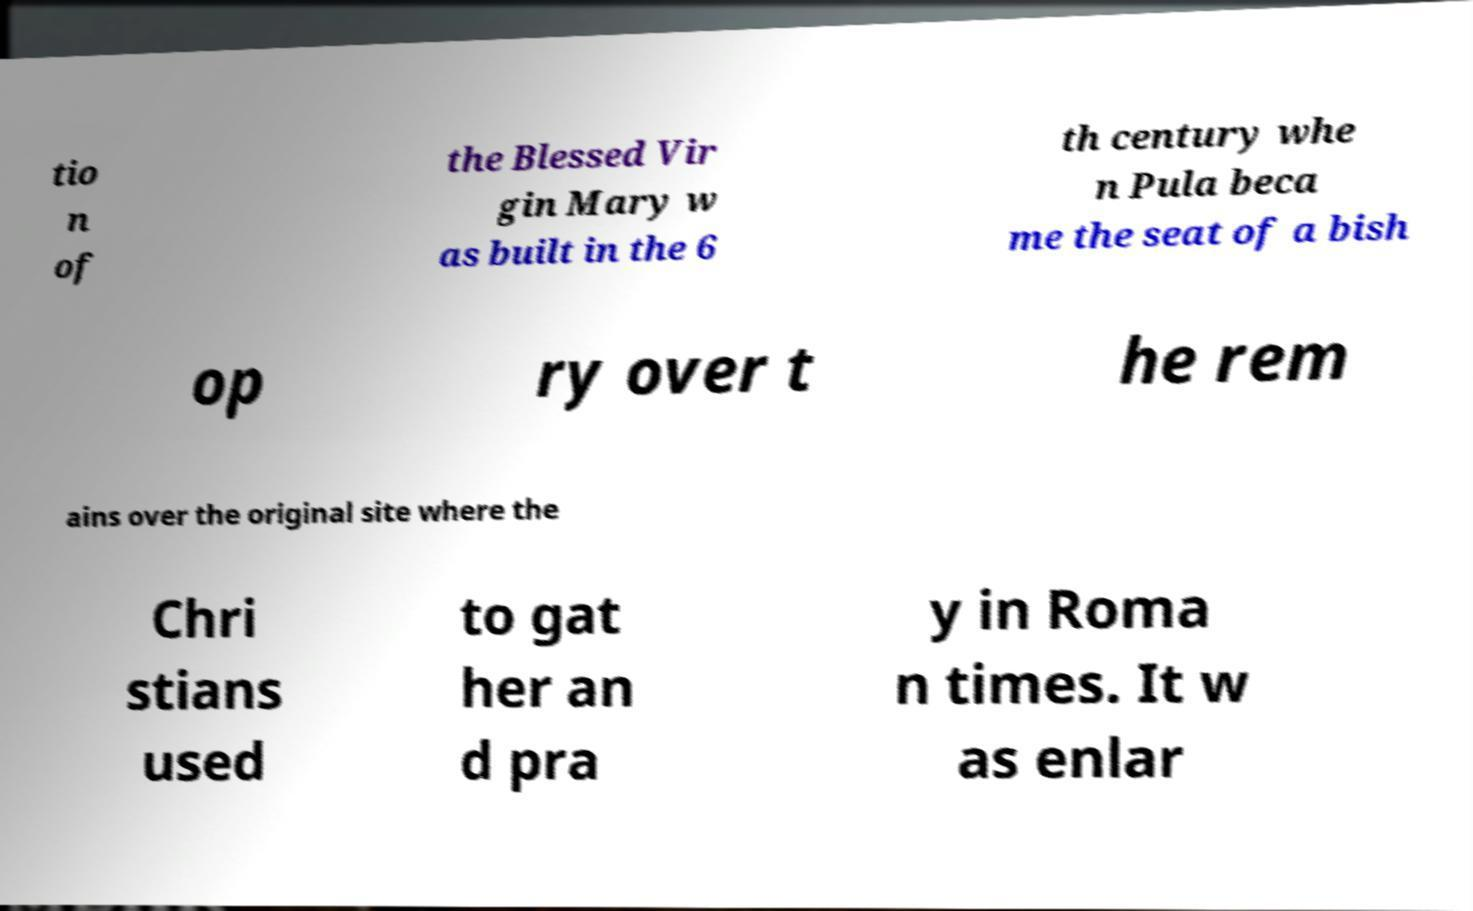Could you assist in decoding the text presented in this image and type it out clearly? tio n of the Blessed Vir gin Mary w as built in the 6 th century whe n Pula beca me the seat of a bish op ry over t he rem ains over the original site where the Chri stians used to gat her an d pra y in Roma n times. It w as enlar 